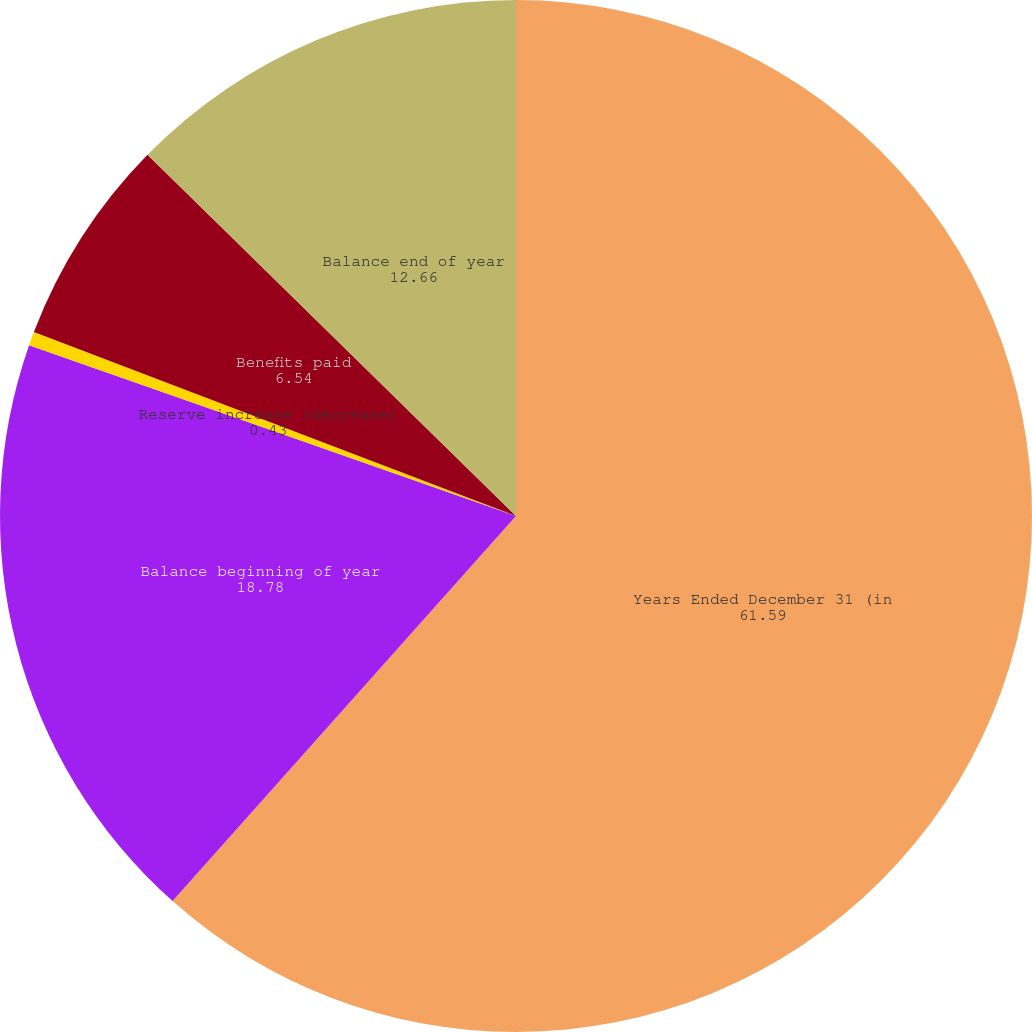<chart> <loc_0><loc_0><loc_500><loc_500><pie_chart><fcel>Years Ended December 31 (in<fcel>Balance beginning of year<fcel>Reserve increase (decrease)<fcel>Benefits paid<fcel>Balance end of year<nl><fcel>61.59%<fcel>18.78%<fcel>0.43%<fcel>6.54%<fcel>12.66%<nl></chart> 